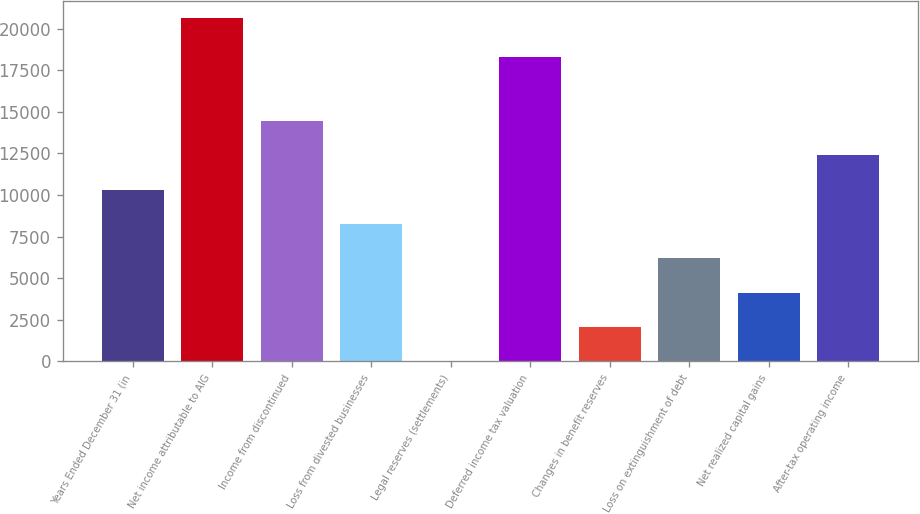<chart> <loc_0><loc_0><loc_500><loc_500><bar_chart><fcel>Years Ended December 31 (in<fcel>Net income attributable to AIG<fcel>Income from discontinued<fcel>Loss from divested businesses<fcel>Legal reserves (settlements)<fcel>Deferred income tax valuation<fcel>Changes in benefit reserves<fcel>Loss on extinguishment of debt<fcel>Net realized capital gains<fcel>After-tax operating income<nl><fcel>10317.5<fcel>20622<fcel>14439.3<fcel>8256.6<fcel>13<fcel>18307<fcel>2073.9<fcel>6195.7<fcel>4134.8<fcel>12378.4<nl></chart> 